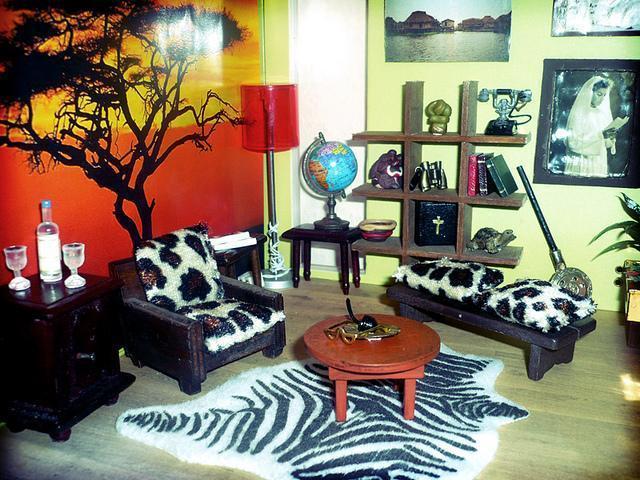How many couches are visible?
Give a very brief answer. 2. How many people are going surfing?
Give a very brief answer. 0. 